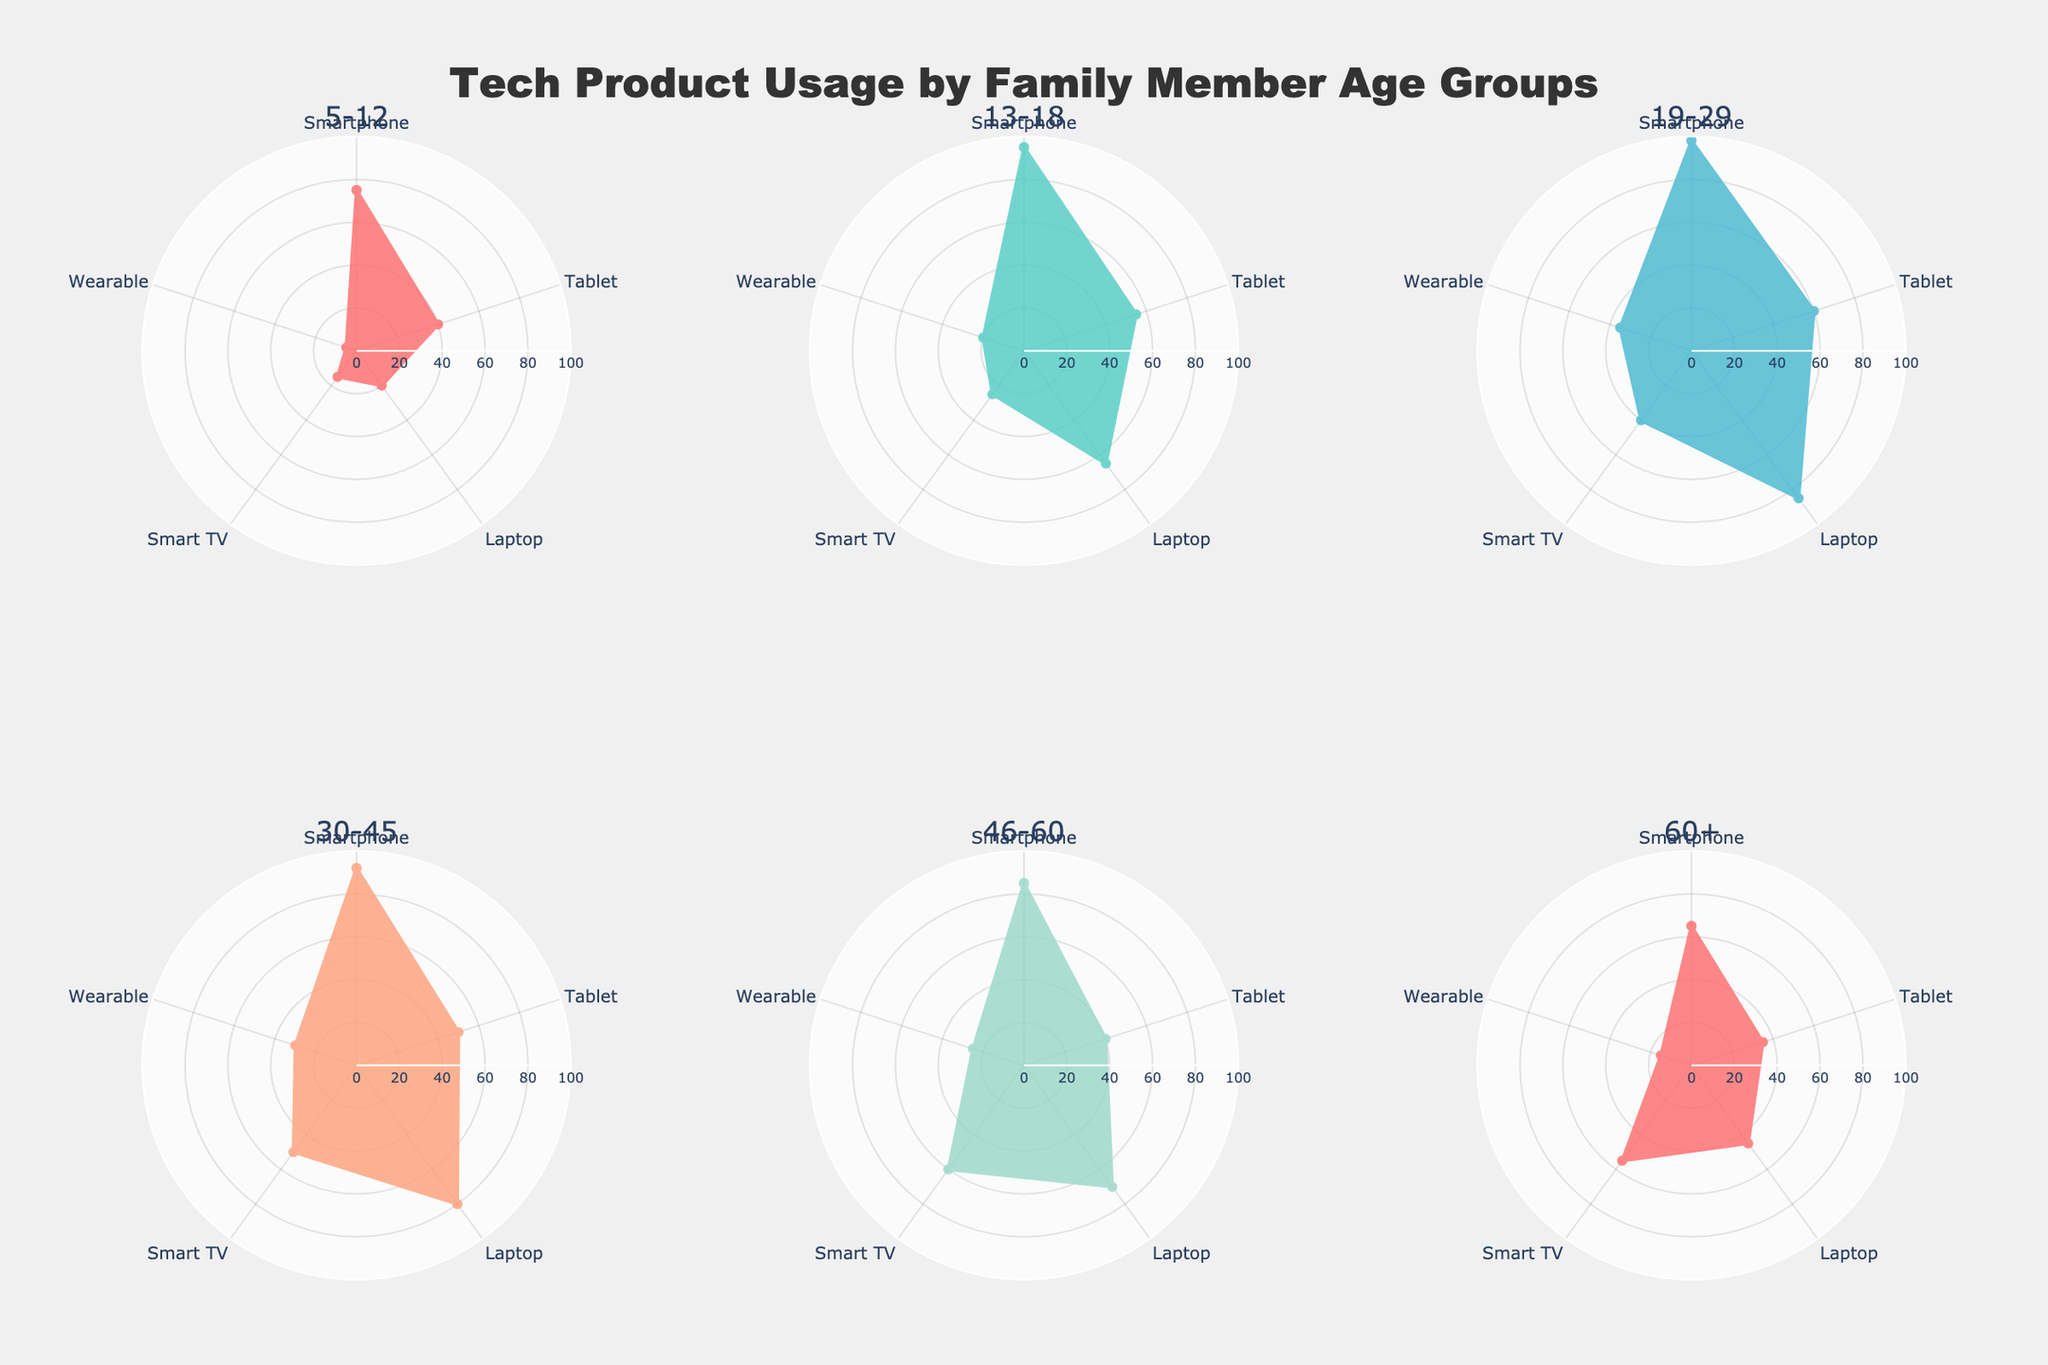What is the age group with the highest smartphone usage? By examining all the rose charts, the age group 19-29 shows the highest smartphone usage reaching almost the outermost section of the chart.
Answer: 19-29 What tech product has the least usage among children aged 5-12? In the subplot for the 5-12 age group, the "Wearable" usage reaches the innermost section of the chart, indicating the lowest percentage at 5%.
Answer: Wearable Compare the tablet usage between age groups 30-45 and 46-60. Which group uses tablets more? Comparing the subplots for age groups 30-45 and 46-60, the tablet usage for both groups is 50% and 40%, respectively.
Answer: 30-45 Which tech product sees the highest increase in usage as users transition from age group 13-18 to age group 19-29? By comparing the subplots for ages 13-18 and 19-29, the "Laptop" usage increases the most, from 65% to 85%, a 20% leap.
Answer: Laptop Identify two age groups where the usage of Smart TVs is exactly the same. Looking at all the subplots, age groups 13-18 and 19-29 both have Smart TV usage at 25%.
Answer: 13-18 and 19-29 What is the average wearable usage across all age groups? Summing up the wearable usages across all age groups (5 + 20 + 35 + 30 + 25 + 15) and dividing by the number of age groups (6) gives (130/6) = 21.67%.
Answer: 21.67% In which age group is the difference between smartphone and wearable usage the highest? The age group 5-12 has a smartphone usage of 75% and wearable usage of 5%, giving a difference of 70%, the highest among all groups.
Answer: 5-12 Is the laptop usage by age group 60+ closer to the usage in age group 5-12 or age group 46-60? The laptop usage for age 60+ is 45%, for age 5-12 is 20%, and for 46-60 is 70%. The difference from 60+ to 46-60 is 25% and to 5-12 is 25%. Hence, the usage is equally close to both age groups.
Answer: Both equally What is the common color used for the 19-29 age group across its subplot? The color used for the age group 19-29 is a shade of light blue (#45B7D1), observed in its subplot.
Answer: Light Blue 